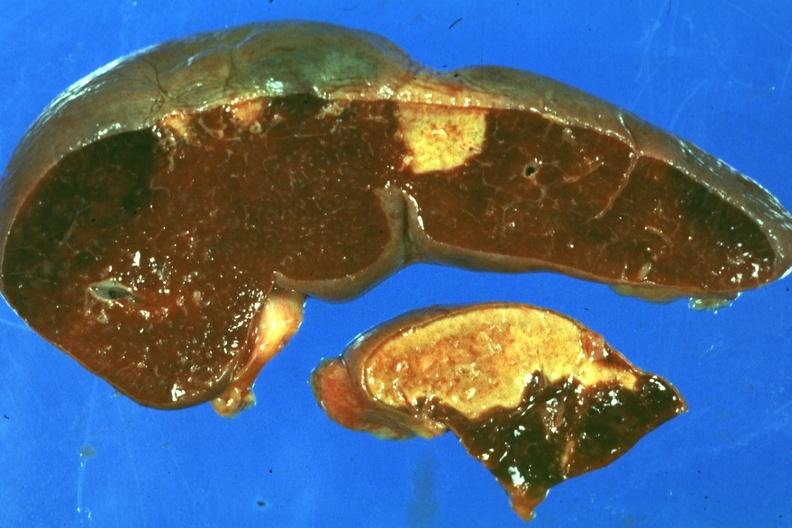s hematologic present?
Answer the question using a single word or phrase. Yes 